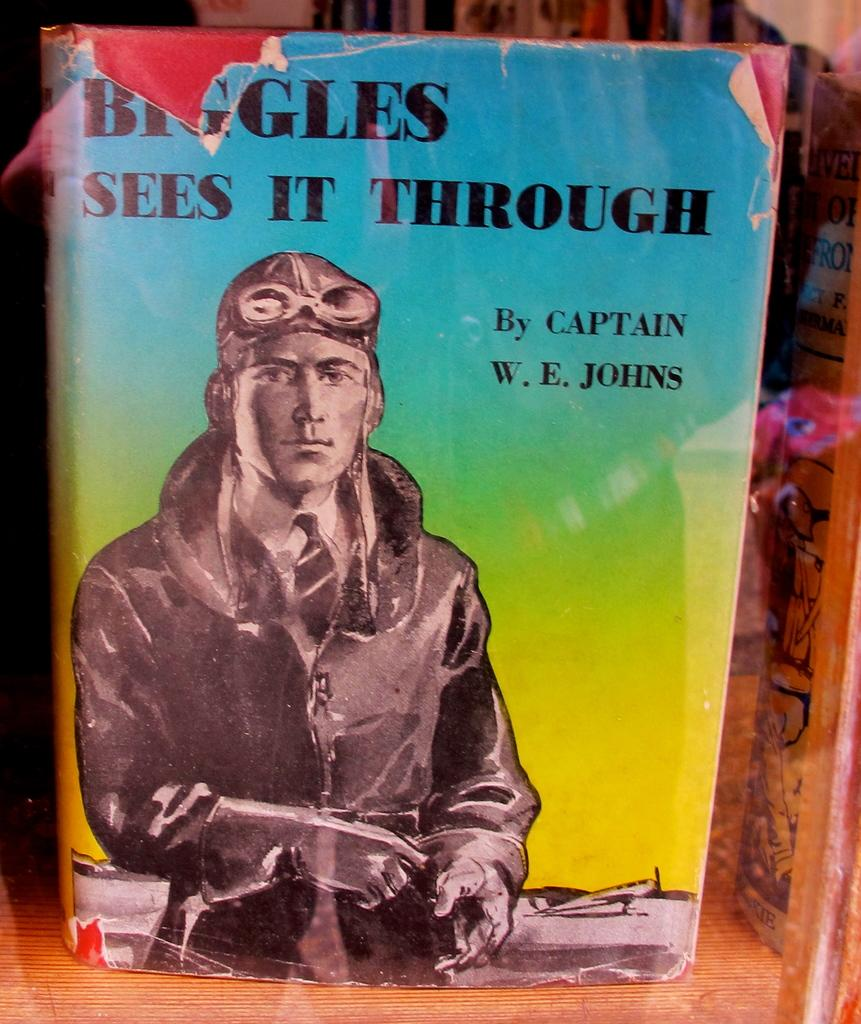<image>
Write a terse but informative summary of the picture. A worn out book by a person with the surname Johns. 